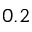Convert formula to latex. <formula><loc_0><loc_0><loc_500><loc_500>0 . 2</formula> 